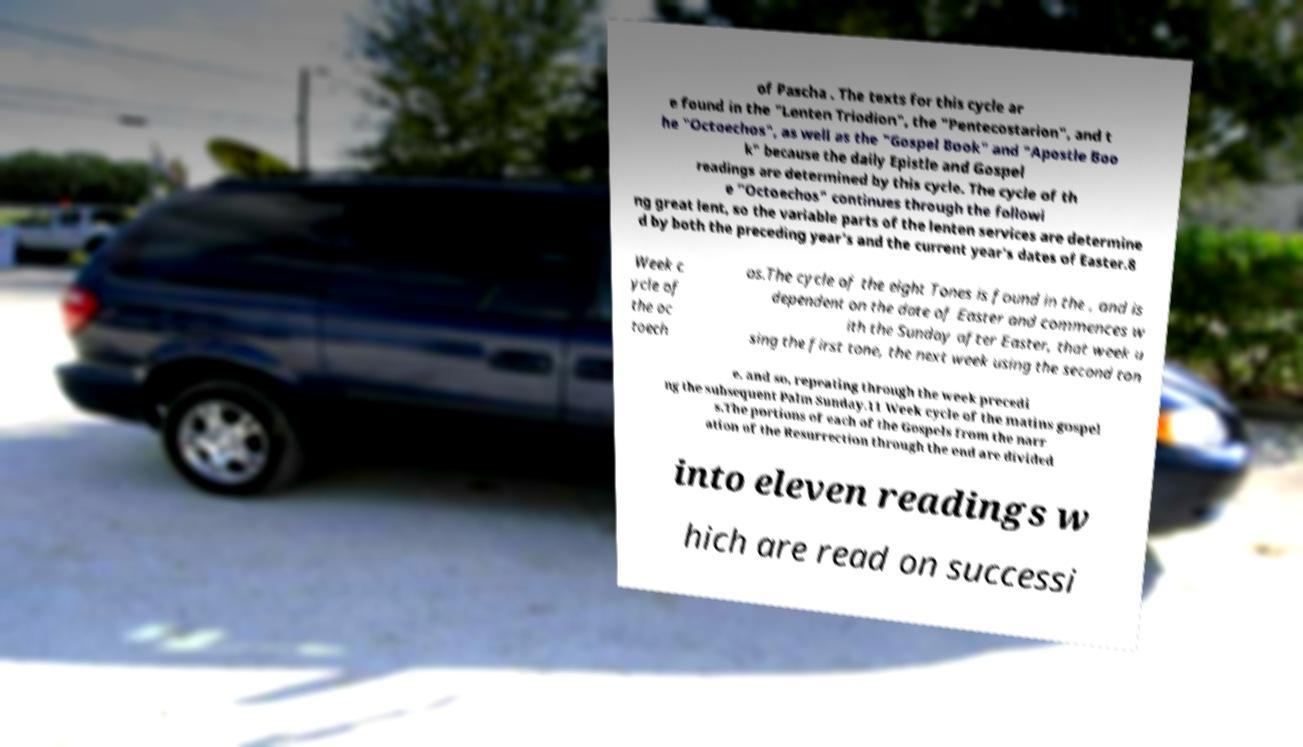Could you assist in decoding the text presented in this image and type it out clearly? of Pascha . The texts for this cycle ar e found in the "Lenten Triodion", the "Pentecostarion", and t he "Octoechos", as well as the "Gospel Book" and "Apostle Boo k" because the daily Epistle and Gospel readings are determined by this cycle. The cycle of th e "Octoechos" continues through the followi ng great lent, so the variable parts of the lenten services are determine d by both the preceding year's and the current year's dates of Easter.8 Week c ycle of the oc toech os.The cycle of the eight Tones is found in the , and is dependent on the date of Easter and commences w ith the Sunday after Easter, that week u sing the first tone, the next week using the second ton e, and so, repeating through the week precedi ng the subsequent Palm Sunday.11 Week cycle of the matins gospel s.The portions of each of the Gospels from the narr ation of the Resurrection through the end are divided into eleven readings w hich are read on successi 